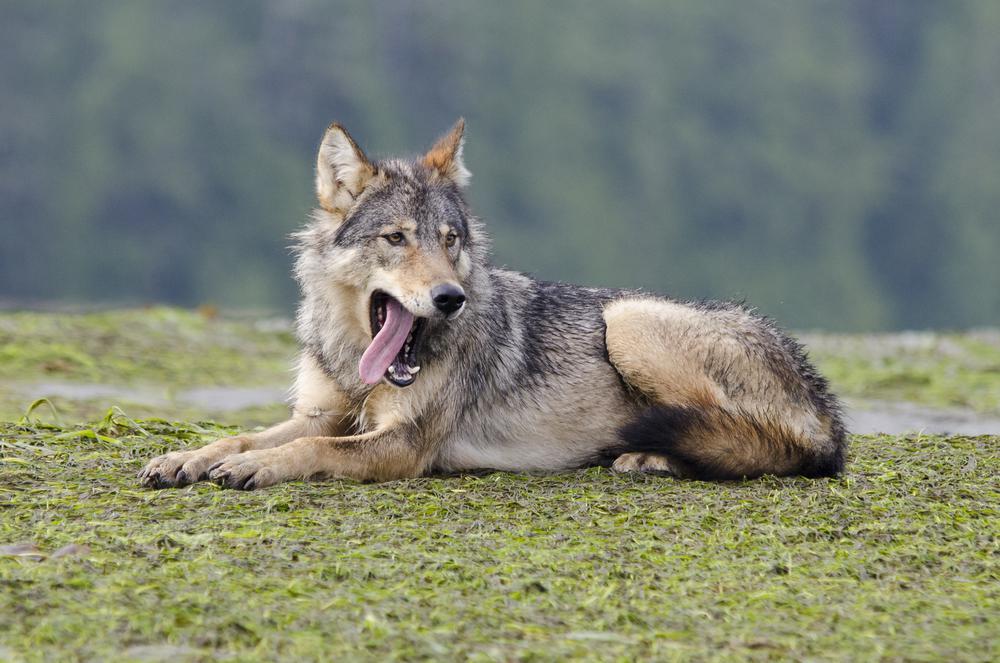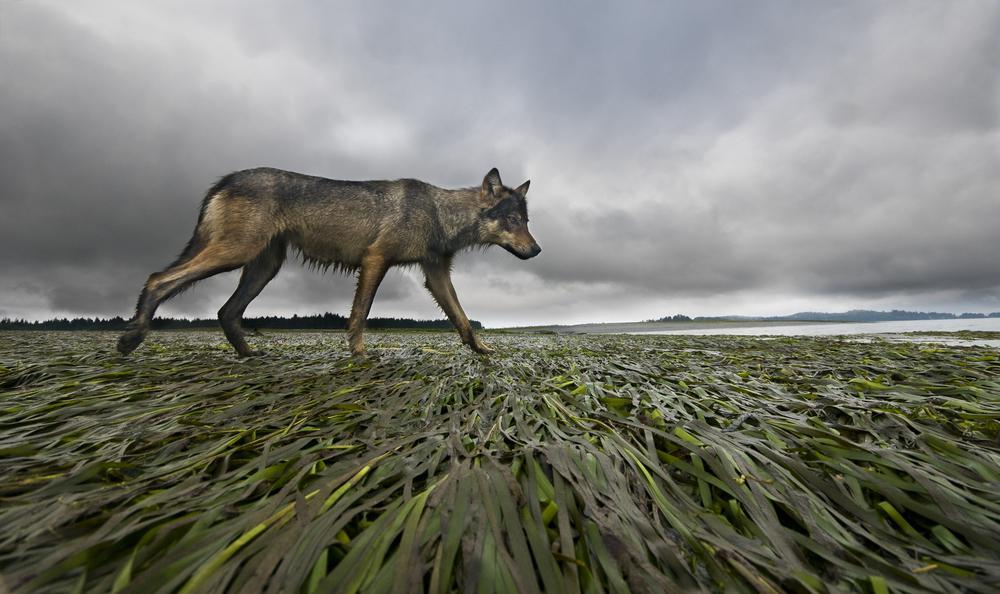The first image is the image on the left, the second image is the image on the right. Examine the images to the left and right. Is the description "A wolf is lying down in one picture and standing in the other." accurate? Answer yes or no. Yes. The first image is the image on the left, the second image is the image on the right. Evaluate the accuracy of this statement regarding the images: "There is a total of 1 adult wolf laying down.". Is it true? Answer yes or no. Yes. 